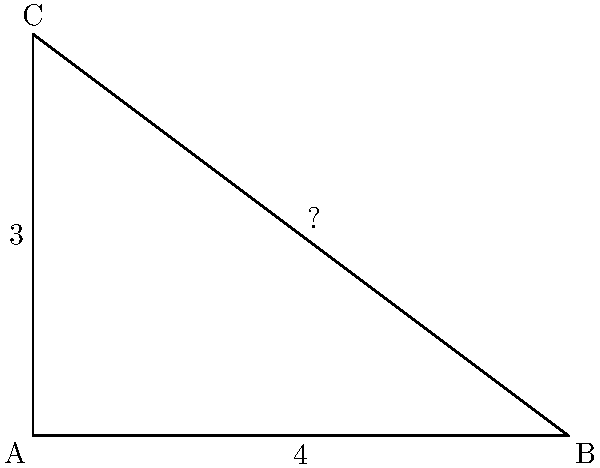Ugh, another geometry problem! As if dealing with my malfunctioning smartphone wasn't frustrating enough. In this annoyingly perfect right-angled triangle ABC, the length of side AB is 4 units, and the length of side AC is 3 units. What's the measure of angle B? Round your answer to the nearest degree, because who has time for decimal places anyway? Alright, let's get this over with:

1) In a right-angled triangle, we can use the trigonometric function tangent to find an angle when we know the opposite and adjacent sides.

2) For angle B, the opposite side is AC (3 units) and the adjacent side is AB (4 units).

3) The tangent of angle B is given by:

   $\tan B = \frac{\text{opposite}}{\text{adjacent}} = \frac{3}{4}$

4) To find angle B, we need to use the inverse tangent (arctan or $\tan^{-1}$):

   $B = \tan^{-1}(\frac{3}{4})$

5) Using a calculator (because who can do this in their head?):

   $B \approx 36.87°$

6) Rounding to the nearest degree:

   $B \approx 37°$

There, done. Can we go back to complaining about technology now?
Answer: $37°$ 